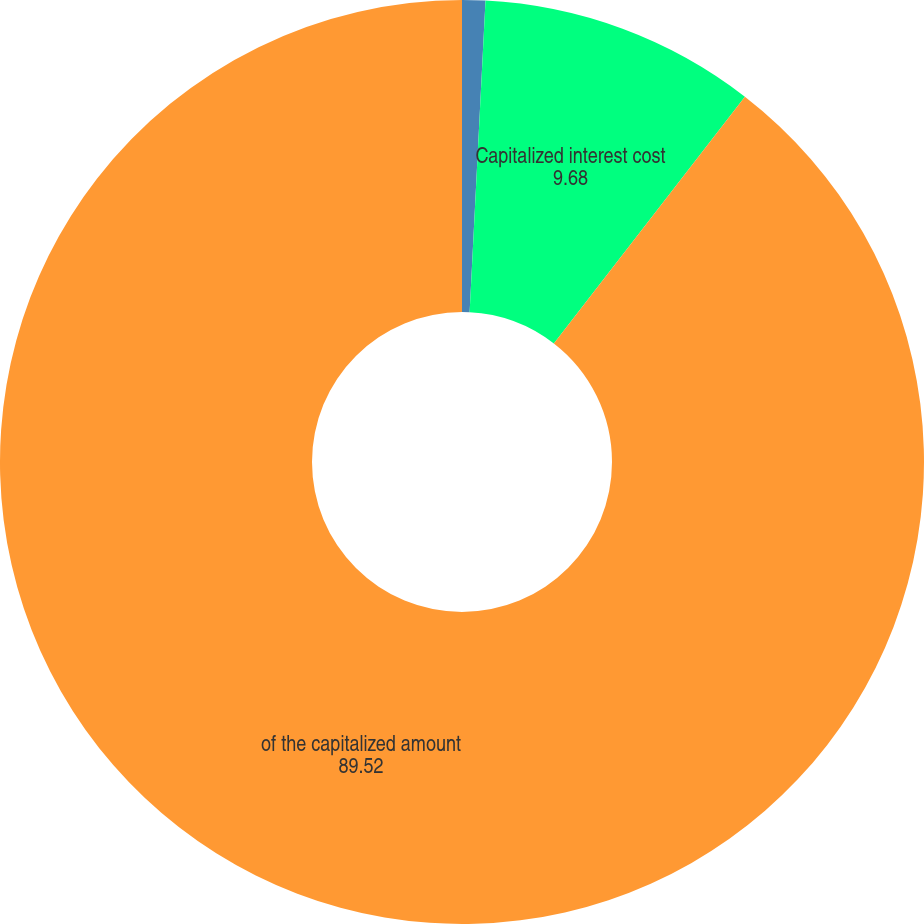<chart> <loc_0><loc_0><loc_500><loc_500><pie_chart><fcel>in thousands<fcel>Capitalized interest cost<fcel>of the capitalized amount<nl><fcel>0.81%<fcel>9.68%<fcel>89.52%<nl></chart> 